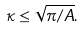Convert formula to latex. <formula><loc_0><loc_0><loc_500><loc_500>\kappa \leq \sqrt { \pi / A } .</formula> 